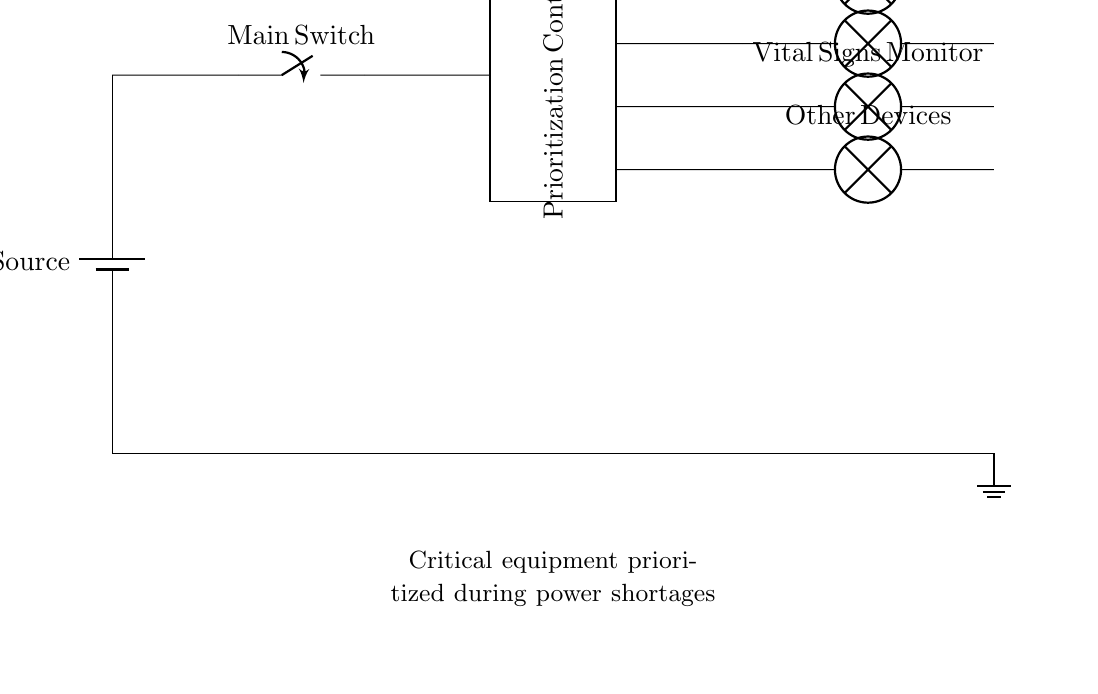What is the type of power source used in the circuit? The circuit uses a battery as a power source, indicated by the battery symbol at the top left of the diagram.
Answer: battery How many devices are connected in the circuit? There are four devices indicated by the four lamp symbols beneath the output lines; each device represents a critical piece of equipment.
Answer: four What is the primary function of the prioritization controller? The prioritization controller is designed to manage which devices receive power, ensuring that critical life-saving equipment is prioritized during power shortages.
Answer: manage power Which device is at the highest priority in this charging circuit? The defibrillator is listed as the first device connected to the output line, indicating it is of higher priority than the others.
Answer: defibrillator What is the connection type between the main switch and the prioritization controller? The connection type between the main switch and the prioritization controller is a short wire connection, as indicated in the diagram by the straight horizontal line.
Answer: short During a power shortage, which devices are expected to receive power first? The output lines show that the defibrillator, ventilator, and vital signs monitor are connected directly to the prioritization controller, indicating they are prioritized to receive power first, before the other devices.
Answer: defibrillator, ventilator, vital signs monitor What is the role of the main switch in this circuit? The main switch controls the flow of power from the battery to the rest of the circuit, enabling or disabling the operation of the entire charging system based on whether it is turned on or off.
Answer: control power flow 